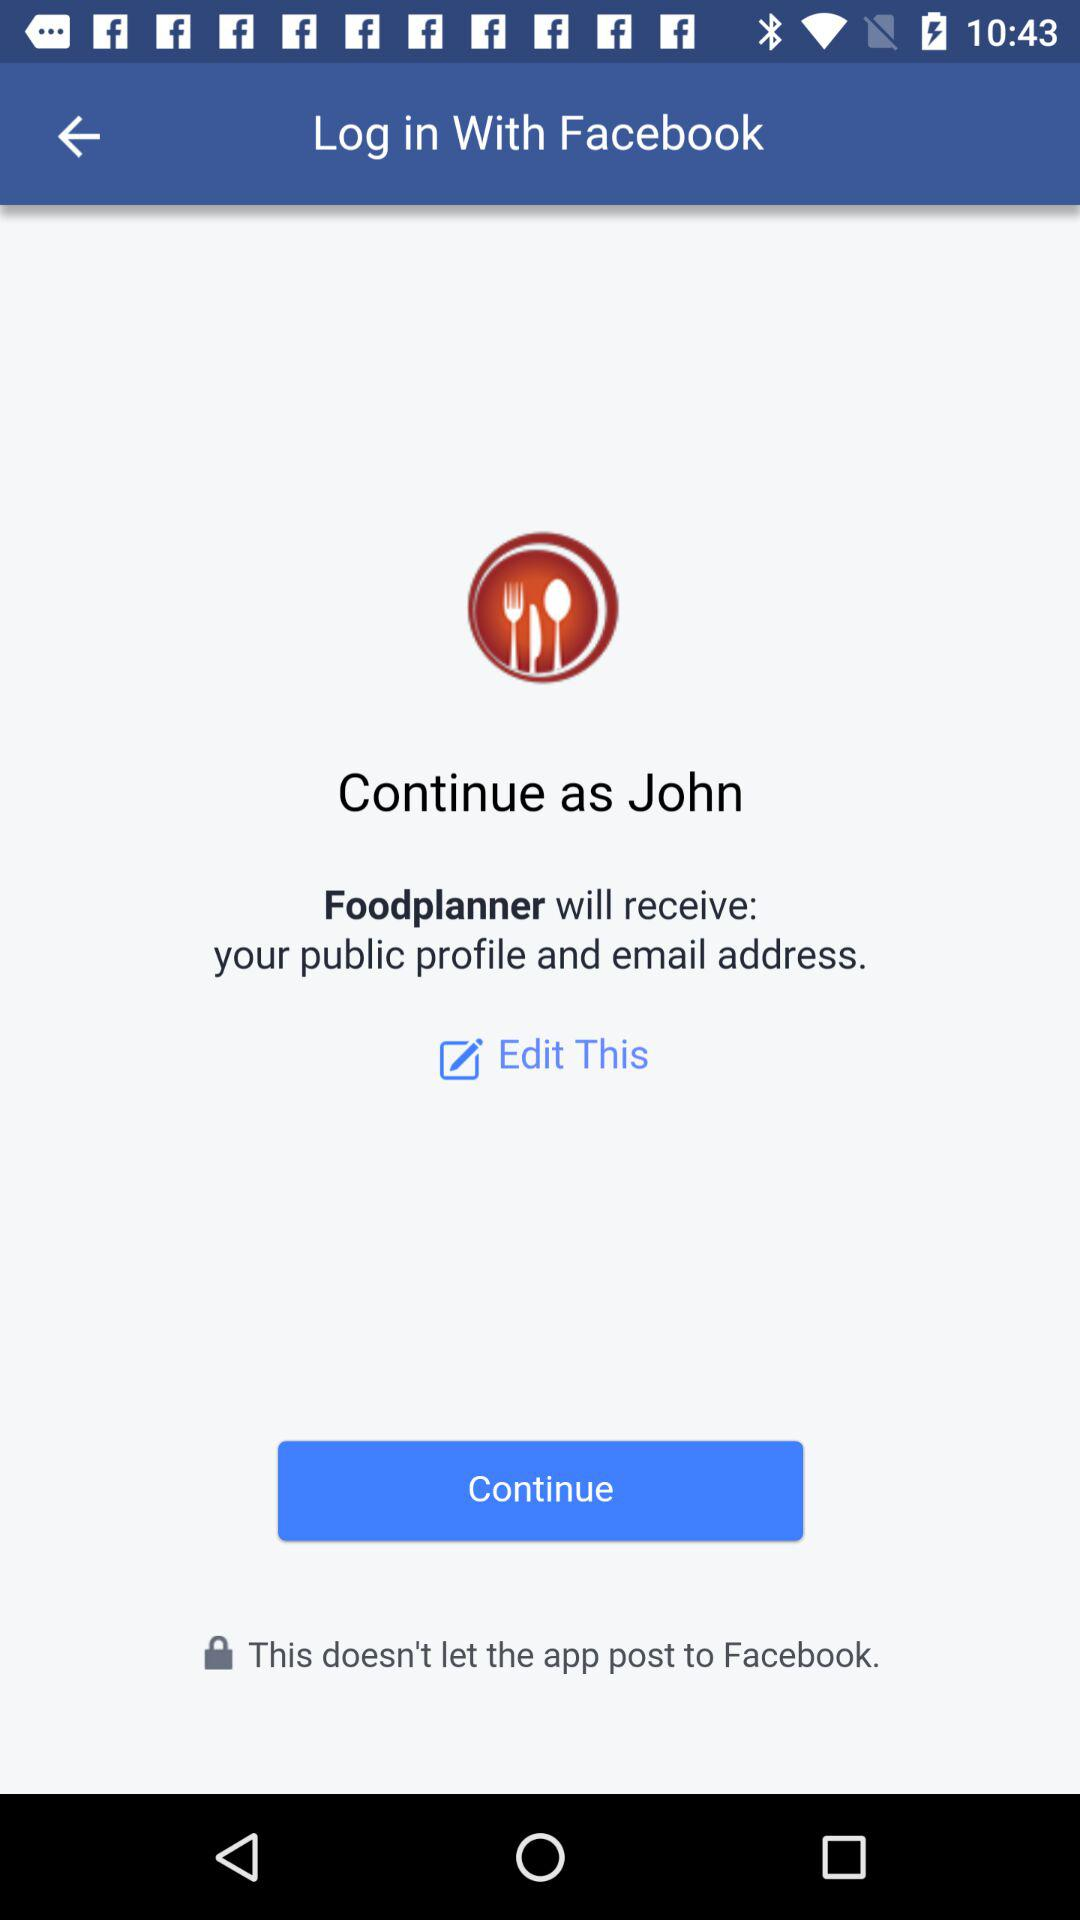What application is asking for permission? The application is "Foodplanner". 